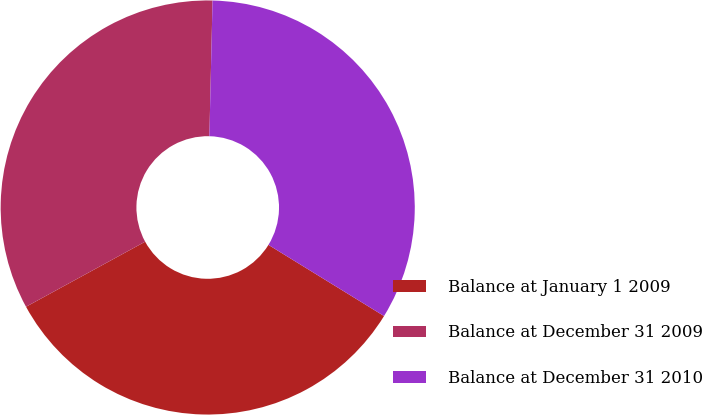Convert chart to OTSL. <chart><loc_0><loc_0><loc_500><loc_500><pie_chart><fcel>Balance at January 1 2009<fcel>Balance at December 31 2009<fcel>Balance at December 31 2010<nl><fcel>33.26%<fcel>33.33%<fcel>33.41%<nl></chart> 